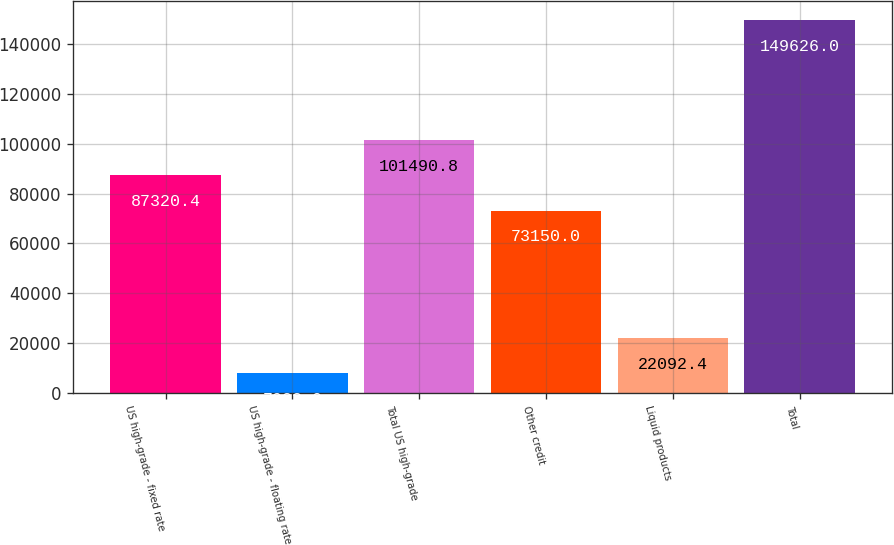Convert chart. <chart><loc_0><loc_0><loc_500><loc_500><bar_chart><fcel>US high-grade - fixed rate<fcel>US high-grade - floating rate<fcel>Total US high-grade<fcel>Other credit<fcel>Liquid products<fcel>Total<nl><fcel>87320.4<fcel>7922<fcel>101491<fcel>73150<fcel>22092.4<fcel>149626<nl></chart> 